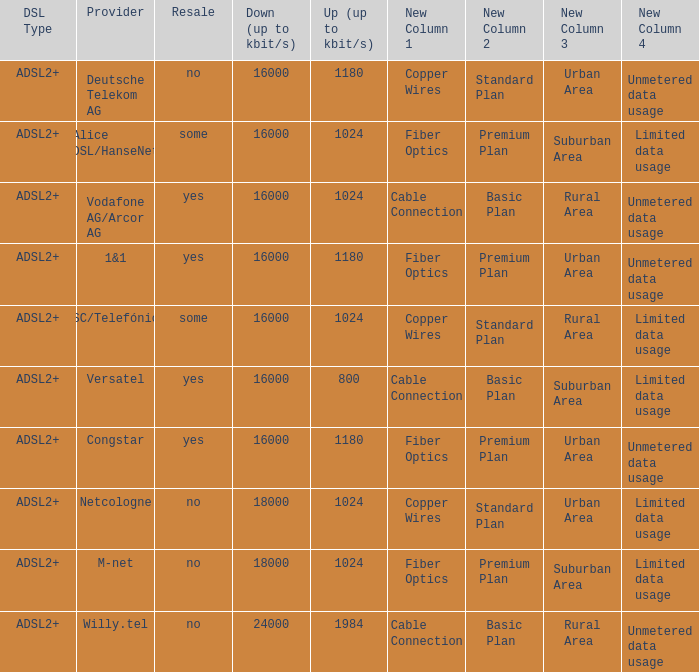What are all the dsl type offered by the M-Net telecom company? ADSL2+. 